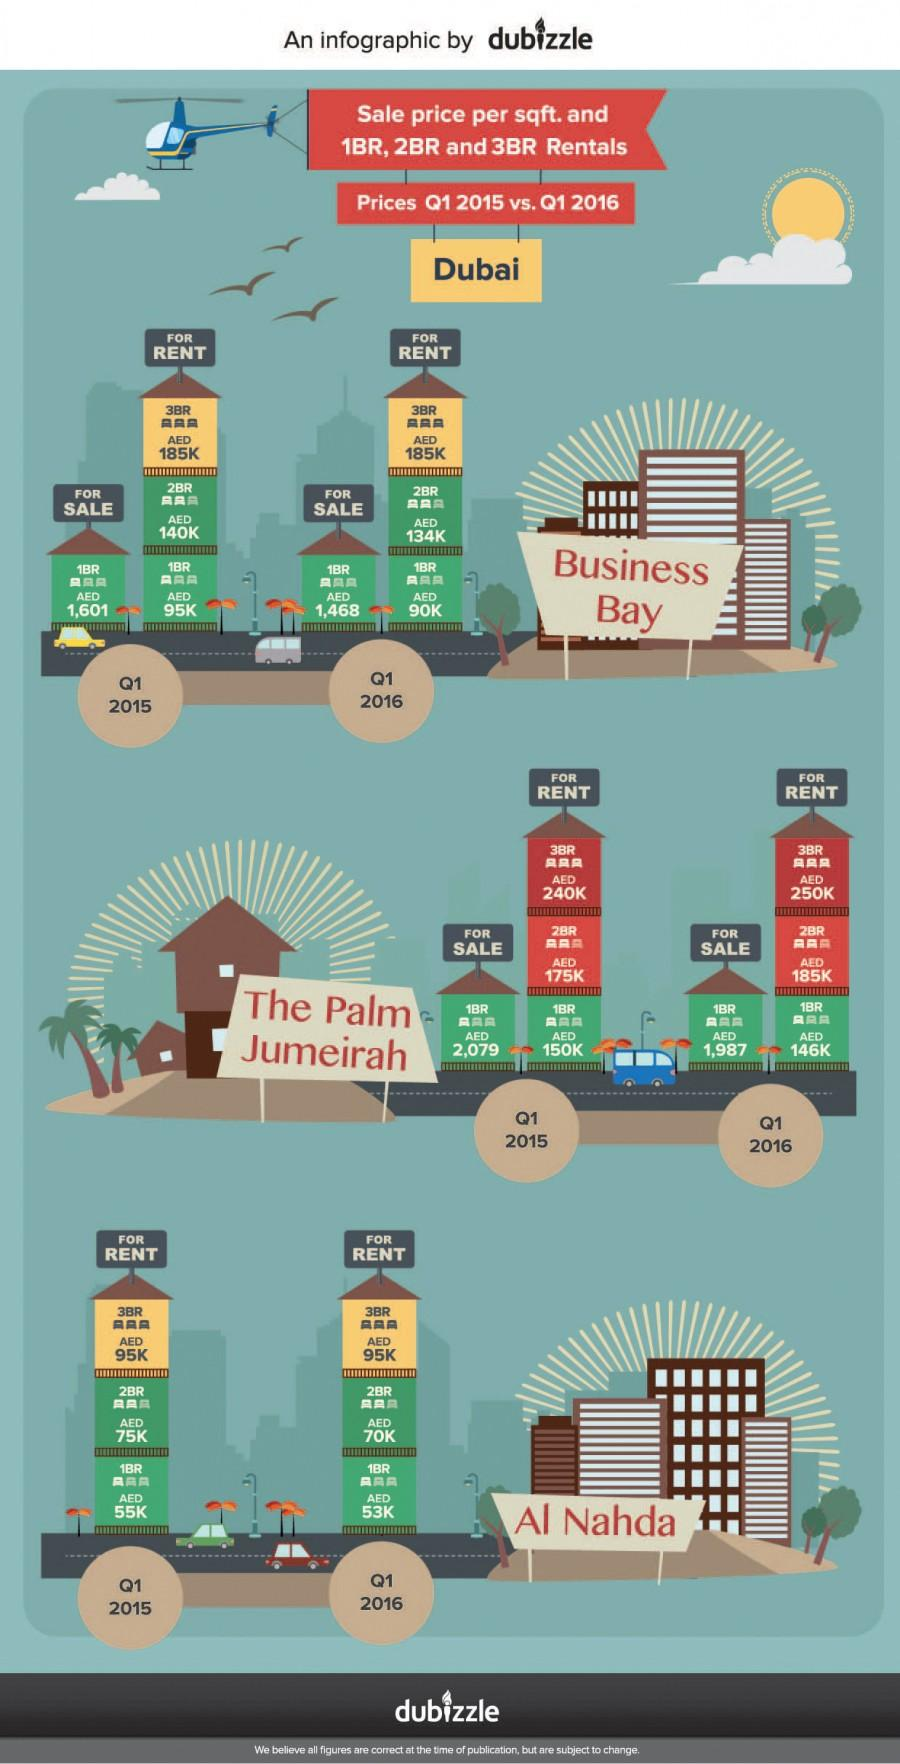Specify some key components in this picture. The monthly rent for a three-bedroom flat in Al Nahda, Dubai during Q1 2015 was approximately AED 95,000. As of Q1 2015, the average rent for a two-bedroom flat in the Palm Jumeirah, Dubai was approximately AED 175K. The average sales price per square foot for a one-bedroom flat in the Palm Jumeirah in Dubai during Q1 2016 was AED 1,987. The sales price per square foot for a one-bedroom flat in Business Bay, Dubai during Q1 2016 was AED 1,468. 